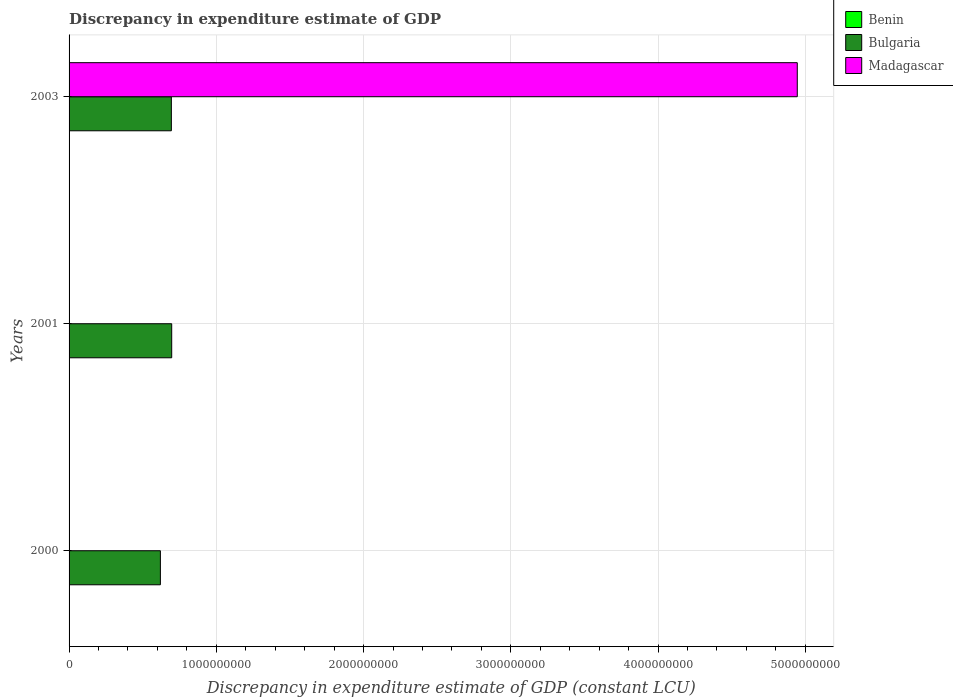How many groups of bars are there?
Keep it short and to the point. 3. Are the number of bars per tick equal to the number of legend labels?
Your answer should be compact. No. Are the number of bars on each tick of the Y-axis equal?
Your response must be concise. No. How many bars are there on the 2nd tick from the bottom?
Keep it short and to the point. 2. In how many cases, is the number of bars for a given year not equal to the number of legend labels?
Give a very brief answer. 2. Across all years, what is the maximum discrepancy in expenditure estimate of GDP in Madagascar?
Make the answer very short. 4.95e+09. Across all years, what is the minimum discrepancy in expenditure estimate of GDP in Benin?
Your answer should be compact. 100. What is the total discrepancy in expenditure estimate of GDP in Bulgaria in the graph?
Offer a terse response. 2.01e+09. What is the difference between the discrepancy in expenditure estimate of GDP in Benin in 2001 and that in 2003?
Offer a terse response. 0. What is the difference between the discrepancy in expenditure estimate of GDP in Madagascar in 2001 and the discrepancy in expenditure estimate of GDP in Bulgaria in 2003?
Provide a succinct answer. -6.95e+08. What is the average discrepancy in expenditure estimate of GDP in Bulgaria per year?
Your response must be concise. 6.71e+08. In the year 2001, what is the difference between the discrepancy in expenditure estimate of GDP in Bulgaria and discrepancy in expenditure estimate of GDP in Benin?
Ensure brevity in your answer.  6.97e+08. In how many years, is the discrepancy in expenditure estimate of GDP in Benin greater than 200000000 LCU?
Your answer should be very brief. 0. Is the discrepancy in expenditure estimate of GDP in Bulgaria in 2000 less than that in 2003?
Keep it short and to the point. Yes. What is the difference between the highest and the second highest discrepancy in expenditure estimate of GDP in Benin?
Give a very brief answer. 0. What is the difference between the highest and the lowest discrepancy in expenditure estimate of GDP in Madagascar?
Your answer should be very brief. 4.95e+09. Is the sum of the discrepancy in expenditure estimate of GDP in Bulgaria in 2000 and 2001 greater than the maximum discrepancy in expenditure estimate of GDP in Madagascar across all years?
Keep it short and to the point. No. Is it the case that in every year, the sum of the discrepancy in expenditure estimate of GDP in Benin and discrepancy in expenditure estimate of GDP in Madagascar is greater than the discrepancy in expenditure estimate of GDP in Bulgaria?
Provide a succinct answer. No. Are all the bars in the graph horizontal?
Provide a succinct answer. Yes. How many years are there in the graph?
Keep it short and to the point. 3. What is the difference between two consecutive major ticks on the X-axis?
Offer a terse response. 1.00e+09. Are the values on the major ticks of X-axis written in scientific E-notation?
Offer a terse response. No. Does the graph contain any zero values?
Offer a very short reply. Yes. Does the graph contain grids?
Ensure brevity in your answer.  Yes. How are the legend labels stacked?
Your answer should be compact. Vertical. What is the title of the graph?
Provide a succinct answer. Discrepancy in expenditure estimate of GDP. What is the label or title of the X-axis?
Keep it short and to the point. Discrepancy in expenditure estimate of GDP (constant LCU). What is the Discrepancy in expenditure estimate of GDP (constant LCU) of Bulgaria in 2000?
Provide a succinct answer. 6.20e+08. What is the Discrepancy in expenditure estimate of GDP (constant LCU) of Madagascar in 2000?
Your answer should be very brief. 0. What is the Discrepancy in expenditure estimate of GDP (constant LCU) of Benin in 2001?
Make the answer very short. 100. What is the Discrepancy in expenditure estimate of GDP (constant LCU) in Bulgaria in 2001?
Your response must be concise. 6.97e+08. What is the Discrepancy in expenditure estimate of GDP (constant LCU) of Bulgaria in 2003?
Provide a succinct answer. 6.95e+08. What is the Discrepancy in expenditure estimate of GDP (constant LCU) in Madagascar in 2003?
Ensure brevity in your answer.  4.95e+09. Across all years, what is the maximum Discrepancy in expenditure estimate of GDP (constant LCU) of Benin?
Provide a succinct answer. 100. Across all years, what is the maximum Discrepancy in expenditure estimate of GDP (constant LCU) in Bulgaria?
Provide a short and direct response. 6.97e+08. Across all years, what is the maximum Discrepancy in expenditure estimate of GDP (constant LCU) in Madagascar?
Offer a terse response. 4.95e+09. Across all years, what is the minimum Discrepancy in expenditure estimate of GDP (constant LCU) in Bulgaria?
Offer a very short reply. 6.20e+08. Across all years, what is the minimum Discrepancy in expenditure estimate of GDP (constant LCU) of Madagascar?
Provide a succinct answer. 0. What is the total Discrepancy in expenditure estimate of GDP (constant LCU) of Benin in the graph?
Provide a succinct answer. 300. What is the total Discrepancy in expenditure estimate of GDP (constant LCU) in Bulgaria in the graph?
Your response must be concise. 2.01e+09. What is the total Discrepancy in expenditure estimate of GDP (constant LCU) of Madagascar in the graph?
Offer a very short reply. 4.95e+09. What is the difference between the Discrepancy in expenditure estimate of GDP (constant LCU) of Bulgaria in 2000 and that in 2001?
Offer a very short reply. -7.68e+07. What is the difference between the Discrepancy in expenditure estimate of GDP (constant LCU) of Bulgaria in 2000 and that in 2003?
Provide a succinct answer. -7.45e+07. What is the difference between the Discrepancy in expenditure estimate of GDP (constant LCU) of Benin in 2001 and that in 2003?
Ensure brevity in your answer.  0. What is the difference between the Discrepancy in expenditure estimate of GDP (constant LCU) in Bulgaria in 2001 and that in 2003?
Keep it short and to the point. 2.26e+06. What is the difference between the Discrepancy in expenditure estimate of GDP (constant LCU) of Benin in 2000 and the Discrepancy in expenditure estimate of GDP (constant LCU) of Bulgaria in 2001?
Provide a succinct answer. -6.97e+08. What is the difference between the Discrepancy in expenditure estimate of GDP (constant LCU) in Benin in 2000 and the Discrepancy in expenditure estimate of GDP (constant LCU) in Bulgaria in 2003?
Your answer should be compact. -6.95e+08. What is the difference between the Discrepancy in expenditure estimate of GDP (constant LCU) in Benin in 2000 and the Discrepancy in expenditure estimate of GDP (constant LCU) in Madagascar in 2003?
Your answer should be compact. -4.95e+09. What is the difference between the Discrepancy in expenditure estimate of GDP (constant LCU) in Bulgaria in 2000 and the Discrepancy in expenditure estimate of GDP (constant LCU) in Madagascar in 2003?
Give a very brief answer. -4.33e+09. What is the difference between the Discrepancy in expenditure estimate of GDP (constant LCU) of Benin in 2001 and the Discrepancy in expenditure estimate of GDP (constant LCU) of Bulgaria in 2003?
Offer a terse response. -6.95e+08. What is the difference between the Discrepancy in expenditure estimate of GDP (constant LCU) in Benin in 2001 and the Discrepancy in expenditure estimate of GDP (constant LCU) in Madagascar in 2003?
Offer a very short reply. -4.95e+09. What is the difference between the Discrepancy in expenditure estimate of GDP (constant LCU) of Bulgaria in 2001 and the Discrepancy in expenditure estimate of GDP (constant LCU) of Madagascar in 2003?
Keep it short and to the point. -4.25e+09. What is the average Discrepancy in expenditure estimate of GDP (constant LCU) of Bulgaria per year?
Give a very brief answer. 6.71e+08. What is the average Discrepancy in expenditure estimate of GDP (constant LCU) in Madagascar per year?
Offer a very short reply. 1.65e+09. In the year 2000, what is the difference between the Discrepancy in expenditure estimate of GDP (constant LCU) in Benin and Discrepancy in expenditure estimate of GDP (constant LCU) in Bulgaria?
Make the answer very short. -6.20e+08. In the year 2001, what is the difference between the Discrepancy in expenditure estimate of GDP (constant LCU) of Benin and Discrepancy in expenditure estimate of GDP (constant LCU) of Bulgaria?
Give a very brief answer. -6.97e+08. In the year 2003, what is the difference between the Discrepancy in expenditure estimate of GDP (constant LCU) of Benin and Discrepancy in expenditure estimate of GDP (constant LCU) of Bulgaria?
Ensure brevity in your answer.  -6.95e+08. In the year 2003, what is the difference between the Discrepancy in expenditure estimate of GDP (constant LCU) in Benin and Discrepancy in expenditure estimate of GDP (constant LCU) in Madagascar?
Provide a succinct answer. -4.95e+09. In the year 2003, what is the difference between the Discrepancy in expenditure estimate of GDP (constant LCU) in Bulgaria and Discrepancy in expenditure estimate of GDP (constant LCU) in Madagascar?
Give a very brief answer. -4.25e+09. What is the ratio of the Discrepancy in expenditure estimate of GDP (constant LCU) in Benin in 2000 to that in 2001?
Your response must be concise. 1. What is the ratio of the Discrepancy in expenditure estimate of GDP (constant LCU) of Bulgaria in 2000 to that in 2001?
Ensure brevity in your answer.  0.89. What is the ratio of the Discrepancy in expenditure estimate of GDP (constant LCU) in Benin in 2000 to that in 2003?
Provide a short and direct response. 1. What is the ratio of the Discrepancy in expenditure estimate of GDP (constant LCU) of Bulgaria in 2000 to that in 2003?
Provide a succinct answer. 0.89. What is the difference between the highest and the second highest Discrepancy in expenditure estimate of GDP (constant LCU) in Benin?
Your answer should be compact. 0. What is the difference between the highest and the second highest Discrepancy in expenditure estimate of GDP (constant LCU) of Bulgaria?
Give a very brief answer. 2.26e+06. What is the difference between the highest and the lowest Discrepancy in expenditure estimate of GDP (constant LCU) in Bulgaria?
Make the answer very short. 7.68e+07. What is the difference between the highest and the lowest Discrepancy in expenditure estimate of GDP (constant LCU) of Madagascar?
Offer a very short reply. 4.95e+09. 